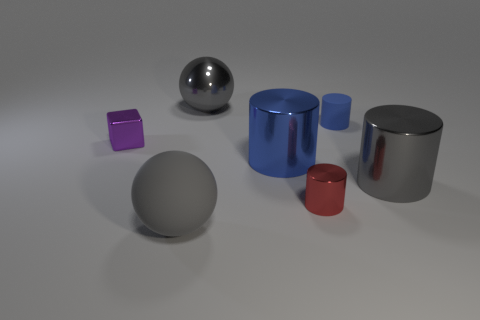There is another tiny object that is made of the same material as the tiny purple object; what color is it?
Ensure brevity in your answer.  Red. Are there fewer purple metal things than gray metal things?
Ensure brevity in your answer.  Yes. There is a big gray thing right of the large metallic sphere; is its shape the same as the matte thing that is behind the tiny purple thing?
Provide a succinct answer. Yes. What number of objects are either tiny gray balls or tiny purple metallic things?
Provide a short and direct response. 1. The other cylinder that is the same size as the gray cylinder is what color?
Your answer should be very brief. Blue. How many tiny cylinders are in front of the small thing to the left of the rubber ball?
Make the answer very short. 1. How many things are behind the tiny metal cylinder and right of the small block?
Your answer should be compact. 4. How many things are either spheres that are behind the tiny purple object or large objects in front of the metal cube?
Offer a very short reply. 4. How many other objects are there of the same size as the gray metallic cylinder?
Provide a succinct answer. 3. There is a metallic object on the right side of the tiny object behind the tiny purple cube; what shape is it?
Make the answer very short. Cylinder. 